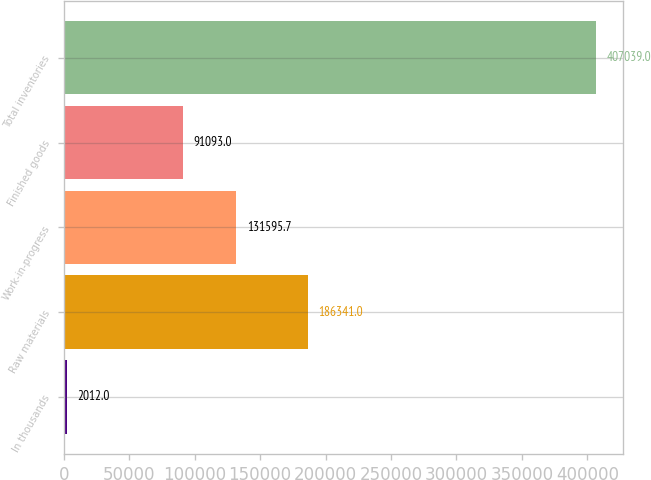Convert chart. <chart><loc_0><loc_0><loc_500><loc_500><bar_chart><fcel>In thousands<fcel>Raw materials<fcel>Work-in-progress<fcel>Finished goods<fcel>Total inventories<nl><fcel>2012<fcel>186341<fcel>131596<fcel>91093<fcel>407039<nl></chart> 